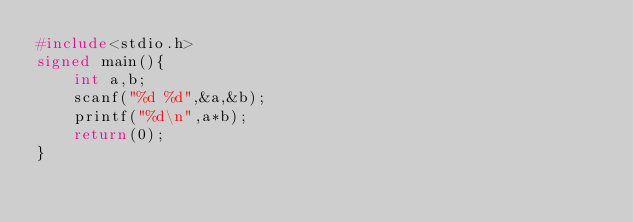<code> <loc_0><loc_0><loc_500><loc_500><_C_>#include<stdio.h>
signed main(){
    int a,b;
    scanf("%d %d",&a,&b);
    printf("%d\n",a*b);
    return(0);
}</code> 